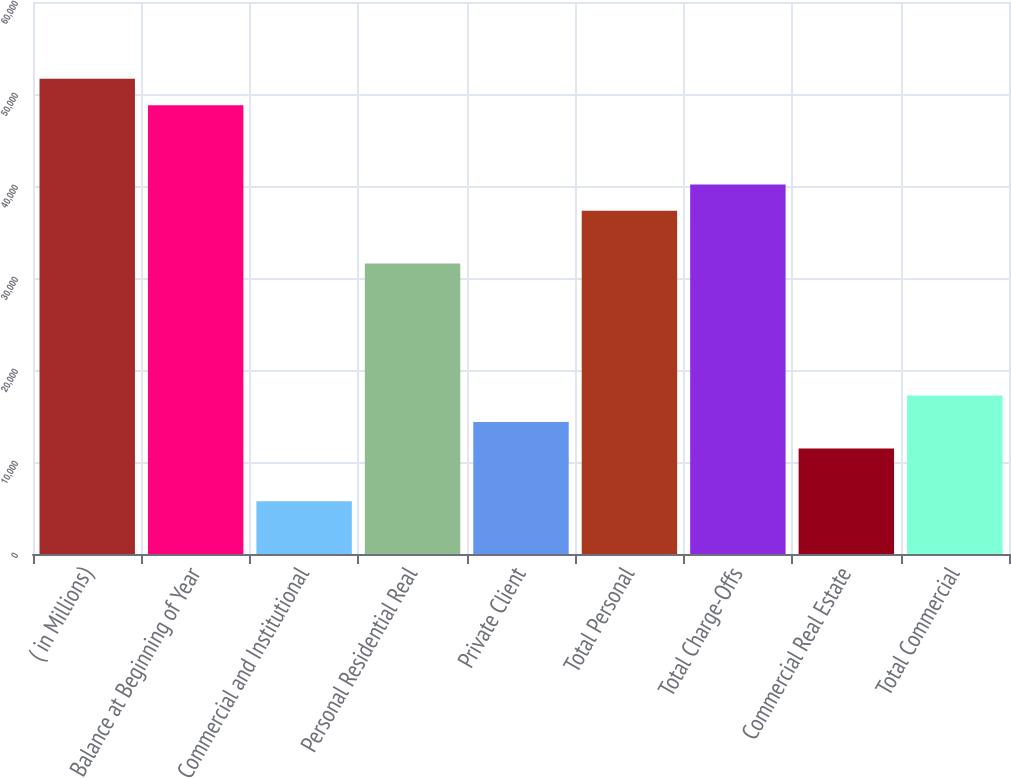<chart> <loc_0><loc_0><loc_500><loc_500><bar_chart><fcel>( in Millions)<fcel>Balance at Beginning of Year<fcel>Commercial and Institutional<fcel>Personal Residential Real<fcel>Private Client<fcel>Total Personal<fcel>Total Charge-Offs<fcel>Commercial Real Estate<fcel>Total Commercial<nl><fcel>51653.7<fcel>48784<fcel>5739.42<fcel>31566.2<fcel>14348.3<fcel>37305.5<fcel>40175.1<fcel>11478.7<fcel>17218<nl></chart> 